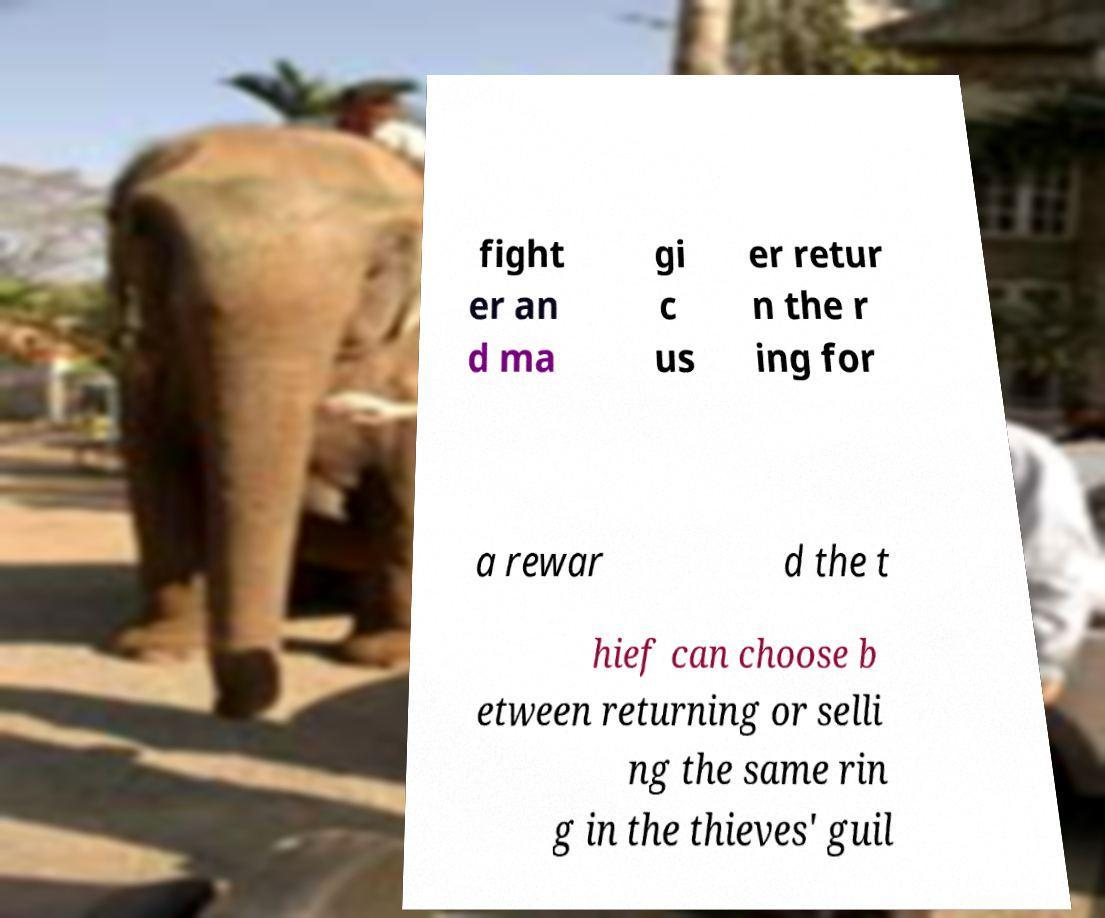Please read and relay the text visible in this image. What does it say? fight er an d ma gi c us er retur n the r ing for a rewar d the t hief can choose b etween returning or selli ng the same rin g in the thieves' guil 